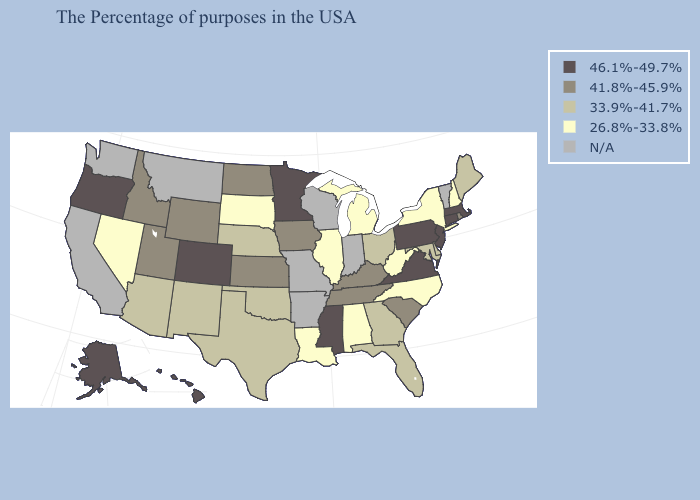Does the map have missing data?
Concise answer only. Yes. Among the states that border Ohio , does Pennsylvania have the highest value?
Quick response, please. Yes. Which states hav the highest value in the South?
Give a very brief answer. Virginia, Mississippi. Among the states that border Maryland , which have the highest value?
Keep it brief. Pennsylvania, Virginia. What is the lowest value in the Northeast?
Answer briefly. 26.8%-33.8%. Which states have the lowest value in the USA?
Short answer required. New Hampshire, New York, North Carolina, West Virginia, Michigan, Alabama, Illinois, Louisiana, South Dakota, Nevada. Among the states that border California , does Arizona have the highest value?
Give a very brief answer. No. Which states have the lowest value in the West?
Give a very brief answer. Nevada. Among the states that border New Jersey , does Pennsylvania have the lowest value?
Write a very short answer. No. What is the highest value in the West ?
Answer briefly. 46.1%-49.7%. Does Minnesota have the highest value in the MidWest?
Write a very short answer. Yes. What is the highest value in states that border Vermont?
Keep it brief. 46.1%-49.7%. How many symbols are there in the legend?
Be succinct. 5. 